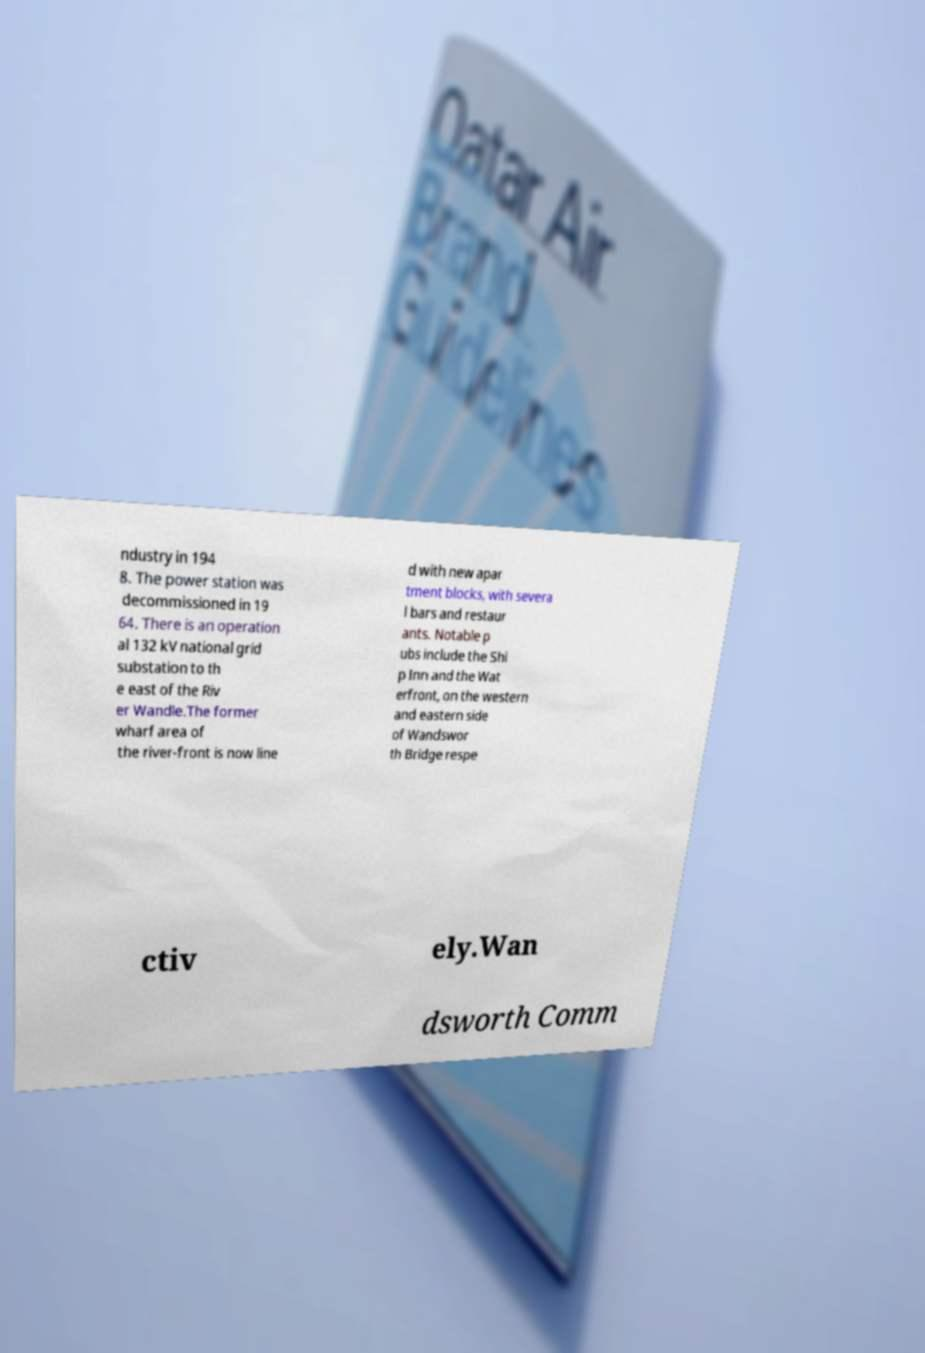Please read and relay the text visible in this image. What does it say? ndustry in 194 8. The power station was decommissioned in 19 64. There is an operation al 132 kV national grid substation to th e east of the Riv er Wandle.The former wharf area of the river-front is now line d with new apar tment blocks, with severa l bars and restaur ants. Notable p ubs include the Shi p Inn and the Wat erfront, on the western and eastern side of Wandswor th Bridge respe ctiv ely.Wan dsworth Comm 